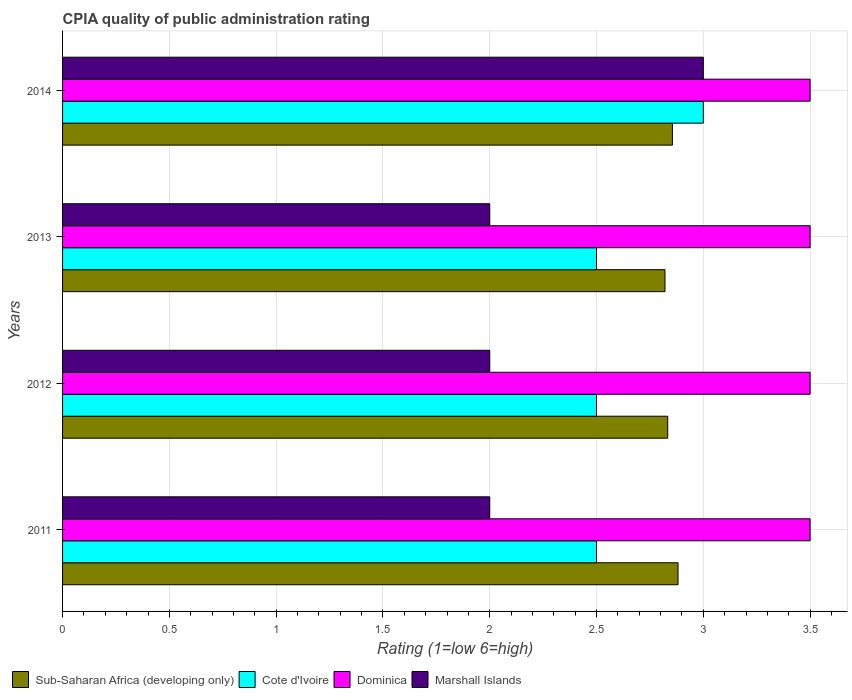How many different coloured bars are there?
Your answer should be compact. 4. How many groups of bars are there?
Ensure brevity in your answer.  4. Are the number of bars per tick equal to the number of legend labels?
Provide a succinct answer. Yes. How many bars are there on the 2nd tick from the top?
Provide a succinct answer. 4. Across all years, what is the maximum CPIA rating in Marshall Islands?
Offer a terse response. 3. Across all years, what is the minimum CPIA rating in Marshall Islands?
Give a very brief answer. 2. In which year was the CPIA rating in Sub-Saharan Africa (developing only) maximum?
Make the answer very short. 2011. What is the difference between the CPIA rating in Cote d'Ivoire in 2014 and the CPIA rating in Sub-Saharan Africa (developing only) in 2013?
Offer a very short reply. 0.18. What is the average CPIA rating in Marshall Islands per year?
Offer a terse response. 2.25. In the year 2013, what is the difference between the CPIA rating in Cote d'Ivoire and CPIA rating in Marshall Islands?
Your answer should be very brief. 0.5. In how many years, is the CPIA rating in Dominica greater than 2.6 ?
Your answer should be compact. 4. What is the ratio of the CPIA rating in Sub-Saharan Africa (developing only) in 2012 to that in 2013?
Your answer should be very brief. 1. Is the CPIA rating in Cote d'Ivoire in 2011 less than that in 2013?
Your response must be concise. No. Is the difference between the CPIA rating in Cote d'Ivoire in 2013 and 2014 greater than the difference between the CPIA rating in Marshall Islands in 2013 and 2014?
Your answer should be compact. Yes. What is the difference between the highest and the second highest CPIA rating in Marshall Islands?
Provide a short and direct response. 1. What is the difference between the highest and the lowest CPIA rating in Cote d'Ivoire?
Your response must be concise. 0.5. In how many years, is the CPIA rating in Cote d'Ivoire greater than the average CPIA rating in Cote d'Ivoire taken over all years?
Keep it short and to the point. 1. Is it the case that in every year, the sum of the CPIA rating in Cote d'Ivoire and CPIA rating in Dominica is greater than the sum of CPIA rating in Marshall Islands and CPIA rating in Sub-Saharan Africa (developing only)?
Ensure brevity in your answer.  Yes. What does the 1st bar from the top in 2014 represents?
Your answer should be very brief. Marshall Islands. What does the 2nd bar from the bottom in 2014 represents?
Make the answer very short. Cote d'Ivoire. Is it the case that in every year, the sum of the CPIA rating in Marshall Islands and CPIA rating in Sub-Saharan Africa (developing only) is greater than the CPIA rating in Dominica?
Your response must be concise. Yes. Are all the bars in the graph horizontal?
Provide a short and direct response. Yes. Does the graph contain grids?
Keep it short and to the point. Yes. How many legend labels are there?
Offer a terse response. 4. How are the legend labels stacked?
Your response must be concise. Horizontal. What is the title of the graph?
Provide a short and direct response. CPIA quality of public administration rating. What is the label or title of the X-axis?
Provide a succinct answer. Rating (1=low 6=high). What is the Rating (1=low 6=high) in Sub-Saharan Africa (developing only) in 2011?
Offer a very short reply. 2.88. What is the Rating (1=low 6=high) of Cote d'Ivoire in 2011?
Your response must be concise. 2.5. What is the Rating (1=low 6=high) of Dominica in 2011?
Your response must be concise. 3.5. What is the Rating (1=low 6=high) in Marshall Islands in 2011?
Give a very brief answer. 2. What is the Rating (1=low 6=high) in Sub-Saharan Africa (developing only) in 2012?
Your answer should be compact. 2.83. What is the Rating (1=low 6=high) of Cote d'Ivoire in 2012?
Provide a succinct answer. 2.5. What is the Rating (1=low 6=high) in Marshall Islands in 2012?
Offer a very short reply. 2. What is the Rating (1=low 6=high) of Sub-Saharan Africa (developing only) in 2013?
Offer a terse response. 2.82. What is the Rating (1=low 6=high) of Cote d'Ivoire in 2013?
Provide a short and direct response. 2.5. What is the Rating (1=low 6=high) of Marshall Islands in 2013?
Provide a succinct answer. 2. What is the Rating (1=low 6=high) of Sub-Saharan Africa (developing only) in 2014?
Offer a very short reply. 2.86. What is the Rating (1=low 6=high) of Dominica in 2014?
Your answer should be very brief. 3.5. What is the Rating (1=low 6=high) in Marshall Islands in 2014?
Provide a succinct answer. 3. Across all years, what is the maximum Rating (1=low 6=high) of Sub-Saharan Africa (developing only)?
Provide a succinct answer. 2.88. Across all years, what is the maximum Rating (1=low 6=high) in Dominica?
Ensure brevity in your answer.  3.5. Across all years, what is the minimum Rating (1=low 6=high) in Sub-Saharan Africa (developing only)?
Your answer should be very brief. 2.82. Across all years, what is the minimum Rating (1=low 6=high) in Marshall Islands?
Make the answer very short. 2. What is the total Rating (1=low 6=high) of Sub-Saharan Africa (developing only) in the graph?
Make the answer very short. 11.39. What is the total Rating (1=low 6=high) of Dominica in the graph?
Provide a succinct answer. 14. What is the total Rating (1=low 6=high) in Marshall Islands in the graph?
Give a very brief answer. 9. What is the difference between the Rating (1=low 6=high) of Sub-Saharan Africa (developing only) in 2011 and that in 2012?
Make the answer very short. 0.05. What is the difference between the Rating (1=low 6=high) in Dominica in 2011 and that in 2012?
Give a very brief answer. 0. What is the difference between the Rating (1=low 6=high) of Sub-Saharan Africa (developing only) in 2011 and that in 2013?
Your answer should be very brief. 0.06. What is the difference between the Rating (1=low 6=high) in Cote d'Ivoire in 2011 and that in 2013?
Offer a very short reply. 0. What is the difference between the Rating (1=low 6=high) of Marshall Islands in 2011 and that in 2013?
Your answer should be compact. 0. What is the difference between the Rating (1=low 6=high) of Sub-Saharan Africa (developing only) in 2011 and that in 2014?
Your answer should be compact. 0.03. What is the difference between the Rating (1=low 6=high) in Cote d'Ivoire in 2011 and that in 2014?
Your answer should be very brief. -0.5. What is the difference between the Rating (1=low 6=high) in Marshall Islands in 2011 and that in 2014?
Keep it short and to the point. -1. What is the difference between the Rating (1=low 6=high) in Sub-Saharan Africa (developing only) in 2012 and that in 2013?
Make the answer very short. 0.01. What is the difference between the Rating (1=low 6=high) of Marshall Islands in 2012 and that in 2013?
Keep it short and to the point. 0. What is the difference between the Rating (1=low 6=high) of Sub-Saharan Africa (developing only) in 2012 and that in 2014?
Give a very brief answer. -0.02. What is the difference between the Rating (1=low 6=high) in Marshall Islands in 2012 and that in 2014?
Your answer should be compact. -1. What is the difference between the Rating (1=low 6=high) of Sub-Saharan Africa (developing only) in 2013 and that in 2014?
Keep it short and to the point. -0.03. What is the difference between the Rating (1=low 6=high) of Cote d'Ivoire in 2013 and that in 2014?
Your answer should be very brief. -0.5. What is the difference between the Rating (1=low 6=high) in Dominica in 2013 and that in 2014?
Your answer should be very brief. 0. What is the difference between the Rating (1=low 6=high) in Marshall Islands in 2013 and that in 2014?
Offer a very short reply. -1. What is the difference between the Rating (1=low 6=high) in Sub-Saharan Africa (developing only) in 2011 and the Rating (1=low 6=high) in Cote d'Ivoire in 2012?
Keep it short and to the point. 0.38. What is the difference between the Rating (1=low 6=high) of Sub-Saharan Africa (developing only) in 2011 and the Rating (1=low 6=high) of Dominica in 2012?
Give a very brief answer. -0.62. What is the difference between the Rating (1=low 6=high) in Sub-Saharan Africa (developing only) in 2011 and the Rating (1=low 6=high) in Marshall Islands in 2012?
Offer a very short reply. 0.88. What is the difference between the Rating (1=low 6=high) of Cote d'Ivoire in 2011 and the Rating (1=low 6=high) of Marshall Islands in 2012?
Keep it short and to the point. 0.5. What is the difference between the Rating (1=low 6=high) of Sub-Saharan Africa (developing only) in 2011 and the Rating (1=low 6=high) of Cote d'Ivoire in 2013?
Your answer should be compact. 0.38. What is the difference between the Rating (1=low 6=high) of Sub-Saharan Africa (developing only) in 2011 and the Rating (1=low 6=high) of Dominica in 2013?
Provide a succinct answer. -0.62. What is the difference between the Rating (1=low 6=high) of Sub-Saharan Africa (developing only) in 2011 and the Rating (1=low 6=high) of Marshall Islands in 2013?
Provide a succinct answer. 0.88. What is the difference between the Rating (1=low 6=high) of Cote d'Ivoire in 2011 and the Rating (1=low 6=high) of Dominica in 2013?
Offer a very short reply. -1. What is the difference between the Rating (1=low 6=high) in Dominica in 2011 and the Rating (1=low 6=high) in Marshall Islands in 2013?
Offer a very short reply. 1.5. What is the difference between the Rating (1=low 6=high) of Sub-Saharan Africa (developing only) in 2011 and the Rating (1=low 6=high) of Cote d'Ivoire in 2014?
Offer a terse response. -0.12. What is the difference between the Rating (1=low 6=high) in Sub-Saharan Africa (developing only) in 2011 and the Rating (1=low 6=high) in Dominica in 2014?
Give a very brief answer. -0.62. What is the difference between the Rating (1=low 6=high) of Sub-Saharan Africa (developing only) in 2011 and the Rating (1=low 6=high) of Marshall Islands in 2014?
Your answer should be very brief. -0.12. What is the difference between the Rating (1=low 6=high) in Cote d'Ivoire in 2011 and the Rating (1=low 6=high) in Dominica in 2014?
Offer a very short reply. -1. What is the difference between the Rating (1=low 6=high) in Dominica in 2011 and the Rating (1=low 6=high) in Marshall Islands in 2014?
Provide a short and direct response. 0.5. What is the difference between the Rating (1=low 6=high) in Sub-Saharan Africa (developing only) in 2012 and the Rating (1=low 6=high) in Cote d'Ivoire in 2013?
Give a very brief answer. 0.33. What is the difference between the Rating (1=low 6=high) of Dominica in 2012 and the Rating (1=low 6=high) of Marshall Islands in 2013?
Offer a terse response. 1.5. What is the difference between the Rating (1=low 6=high) in Sub-Saharan Africa (developing only) in 2012 and the Rating (1=low 6=high) in Dominica in 2014?
Give a very brief answer. -0.67. What is the difference between the Rating (1=low 6=high) of Cote d'Ivoire in 2012 and the Rating (1=low 6=high) of Dominica in 2014?
Ensure brevity in your answer.  -1. What is the difference between the Rating (1=low 6=high) of Dominica in 2012 and the Rating (1=low 6=high) of Marshall Islands in 2014?
Keep it short and to the point. 0.5. What is the difference between the Rating (1=low 6=high) in Sub-Saharan Africa (developing only) in 2013 and the Rating (1=low 6=high) in Cote d'Ivoire in 2014?
Provide a succinct answer. -0.18. What is the difference between the Rating (1=low 6=high) of Sub-Saharan Africa (developing only) in 2013 and the Rating (1=low 6=high) of Dominica in 2014?
Your answer should be compact. -0.68. What is the difference between the Rating (1=low 6=high) of Sub-Saharan Africa (developing only) in 2013 and the Rating (1=low 6=high) of Marshall Islands in 2014?
Offer a terse response. -0.18. What is the difference between the Rating (1=low 6=high) in Cote d'Ivoire in 2013 and the Rating (1=low 6=high) in Dominica in 2014?
Your response must be concise. -1. What is the average Rating (1=low 6=high) of Sub-Saharan Africa (developing only) per year?
Give a very brief answer. 2.85. What is the average Rating (1=low 6=high) of Cote d'Ivoire per year?
Ensure brevity in your answer.  2.62. What is the average Rating (1=low 6=high) in Marshall Islands per year?
Offer a very short reply. 2.25. In the year 2011, what is the difference between the Rating (1=low 6=high) in Sub-Saharan Africa (developing only) and Rating (1=low 6=high) in Cote d'Ivoire?
Your answer should be compact. 0.38. In the year 2011, what is the difference between the Rating (1=low 6=high) in Sub-Saharan Africa (developing only) and Rating (1=low 6=high) in Dominica?
Offer a very short reply. -0.62. In the year 2011, what is the difference between the Rating (1=low 6=high) of Sub-Saharan Africa (developing only) and Rating (1=low 6=high) of Marshall Islands?
Your answer should be compact. 0.88. In the year 2011, what is the difference between the Rating (1=low 6=high) in Cote d'Ivoire and Rating (1=low 6=high) in Dominica?
Your answer should be very brief. -1. In the year 2012, what is the difference between the Rating (1=low 6=high) in Sub-Saharan Africa (developing only) and Rating (1=low 6=high) in Cote d'Ivoire?
Provide a short and direct response. 0.33. In the year 2012, what is the difference between the Rating (1=low 6=high) in Sub-Saharan Africa (developing only) and Rating (1=low 6=high) in Marshall Islands?
Ensure brevity in your answer.  0.83. In the year 2012, what is the difference between the Rating (1=low 6=high) of Cote d'Ivoire and Rating (1=low 6=high) of Dominica?
Provide a succinct answer. -1. In the year 2012, what is the difference between the Rating (1=low 6=high) of Cote d'Ivoire and Rating (1=low 6=high) of Marshall Islands?
Your answer should be very brief. 0.5. In the year 2012, what is the difference between the Rating (1=low 6=high) in Dominica and Rating (1=low 6=high) in Marshall Islands?
Provide a short and direct response. 1.5. In the year 2013, what is the difference between the Rating (1=low 6=high) of Sub-Saharan Africa (developing only) and Rating (1=low 6=high) of Cote d'Ivoire?
Ensure brevity in your answer.  0.32. In the year 2013, what is the difference between the Rating (1=low 6=high) of Sub-Saharan Africa (developing only) and Rating (1=low 6=high) of Dominica?
Provide a succinct answer. -0.68. In the year 2013, what is the difference between the Rating (1=low 6=high) in Sub-Saharan Africa (developing only) and Rating (1=low 6=high) in Marshall Islands?
Offer a terse response. 0.82. In the year 2013, what is the difference between the Rating (1=low 6=high) in Cote d'Ivoire and Rating (1=low 6=high) in Dominica?
Make the answer very short. -1. In the year 2013, what is the difference between the Rating (1=low 6=high) in Dominica and Rating (1=low 6=high) in Marshall Islands?
Your answer should be very brief. 1.5. In the year 2014, what is the difference between the Rating (1=low 6=high) of Sub-Saharan Africa (developing only) and Rating (1=low 6=high) of Cote d'Ivoire?
Your answer should be compact. -0.14. In the year 2014, what is the difference between the Rating (1=low 6=high) of Sub-Saharan Africa (developing only) and Rating (1=low 6=high) of Dominica?
Ensure brevity in your answer.  -0.64. In the year 2014, what is the difference between the Rating (1=low 6=high) in Sub-Saharan Africa (developing only) and Rating (1=low 6=high) in Marshall Islands?
Offer a terse response. -0.14. In the year 2014, what is the difference between the Rating (1=low 6=high) in Dominica and Rating (1=low 6=high) in Marshall Islands?
Ensure brevity in your answer.  0.5. What is the ratio of the Rating (1=low 6=high) in Sub-Saharan Africa (developing only) in 2011 to that in 2012?
Your response must be concise. 1.02. What is the ratio of the Rating (1=low 6=high) of Cote d'Ivoire in 2011 to that in 2012?
Your answer should be very brief. 1. What is the ratio of the Rating (1=low 6=high) of Sub-Saharan Africa (developing only) in 2011 to that in 2013?
Offer a very short reply. 1.02. What is the ratio of the Rating (1=low 6=high) in Cote d'Ivoire in 2011 to that in 2013?
Give a very brief answer. 1. What is the ratio of the Rating (1=low 6=high) of Marshall Islands in 2011 to that in 2013?
Provide a succinct answer. 1. What is the ratio of the Rating (1=low 6=high) in Sub-Saharan Africa (developing only) in 2011 to that in 2014?
Offer a terse response. 1.01. What is the ratio of the Rating (1=low 6=high) of Marshall Islands in 2011 to that in 2014?
Give a very brief answer. 0.67. What is the ratio of the Rating (1=low 6=high) in Dominica in 2012 to that in 2013?
Offer a terse response. 1. What is the ratio of the Rating (1=low 6=high) in Marshall Islands in 2012 to that in 2013?
Make the answer very short. 1. What is the ratio of the Rating (1=low 6=high) of Sub-Saharan Africa (developing only) in 2012 to that in 2014?
Make the answer very short. 0.99. What is the ratio of the Rating (1=low 6=high) in Dominica in 2012 to that in 2014?
Ensure brevity in your answer.  1. What is the ratio of the Rating (1=low 6=high) in Marshall Islands in 2012 to that in 2014?
Your response must be concise. 0.67. What is the ratio of the Rating (1=low 6=high) of Sub-Saharan Africa (developing only) in 2013 to that in 2014?
Offer a terse response. 0.99. What is the ratio of the Rating (1=low 6=high) of Cote d'Ivoire in 2013 to that in 2014?
Provide a short and direct response. 0.83. What is the ratio of the Rating (1=low 6=high) of Marshall Islands in 2013 to that in 2014?
Ensure brevity in your answer.  0.67. What is the difference between the highest and the second highest Rating (1=low 6=high) of Sub-Saharan Africa (developing only)?
Keep it short and to the point. 0.03. What is the difference between the highest and the second highest Rating (1=low 6=high) of Dominica?
Give a very brief answer. 0. What is the difference between the highest and the lowest Rating (1=low 6=high) of Sub-Saharan Africa (developing only)?
Offer a terse response. 0.06. 